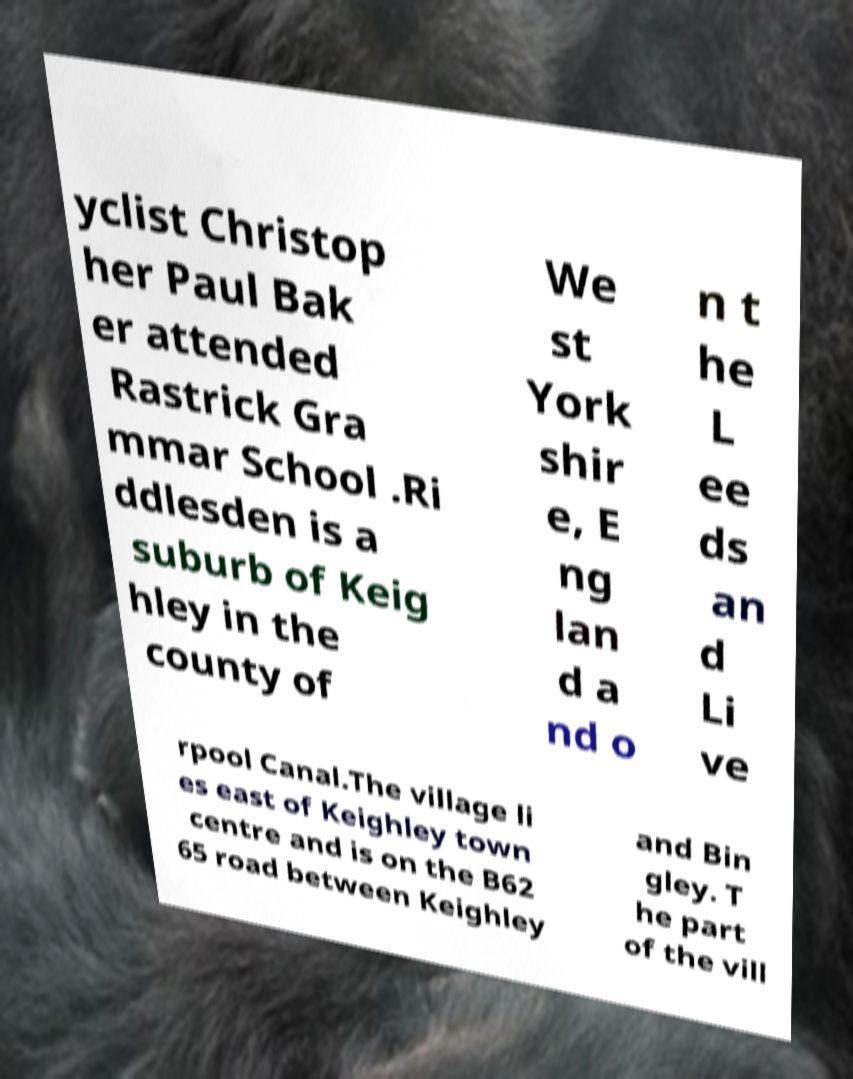Could you extract and type out the text from this image? yclist Christop her Paul Bak er attended Rastrick Gra mmar School .Ri ddlesden is a suburb of Keig hley in the county of We st York shir e, E ng lan d a nd o n t he L ee ds an d Li ve rpool Canal.The village li es east of Keighley town centre and is on the B62 65 road between Keighley and Bin gley. T he part of the vill 